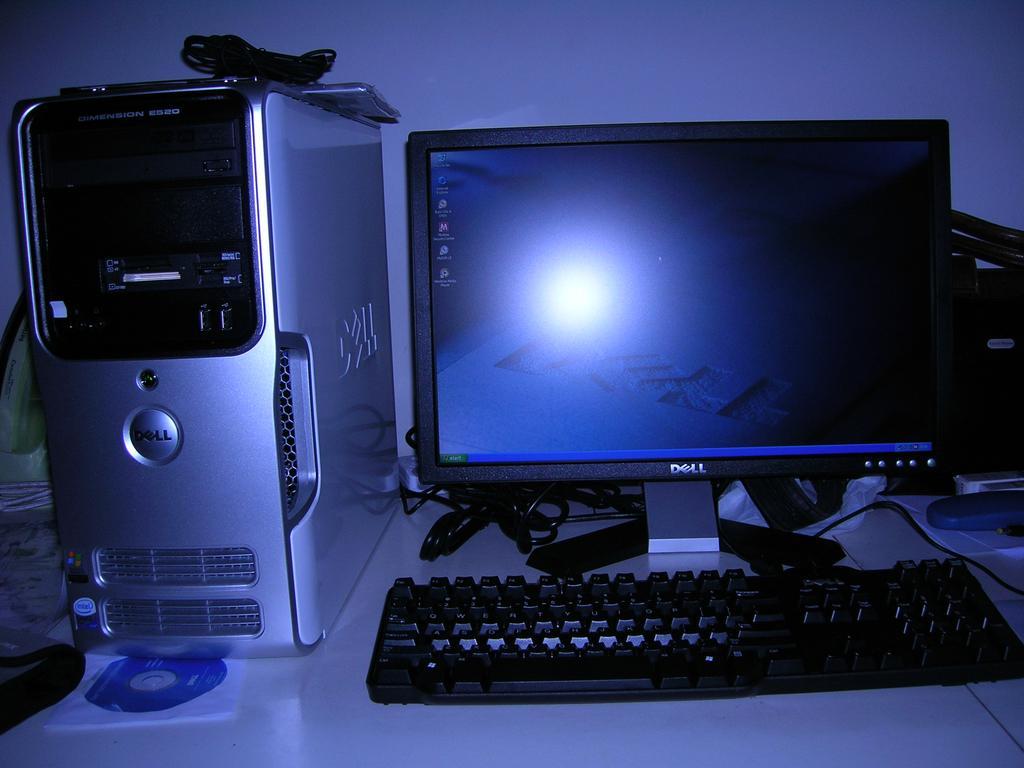Describe this image in one or two sentences. In this picture there is a monitor in the center of the image and a CPU on the left side of the image, there are wires on the CPU, there is a CD at the bottom side of the image, which are placed on desk. 